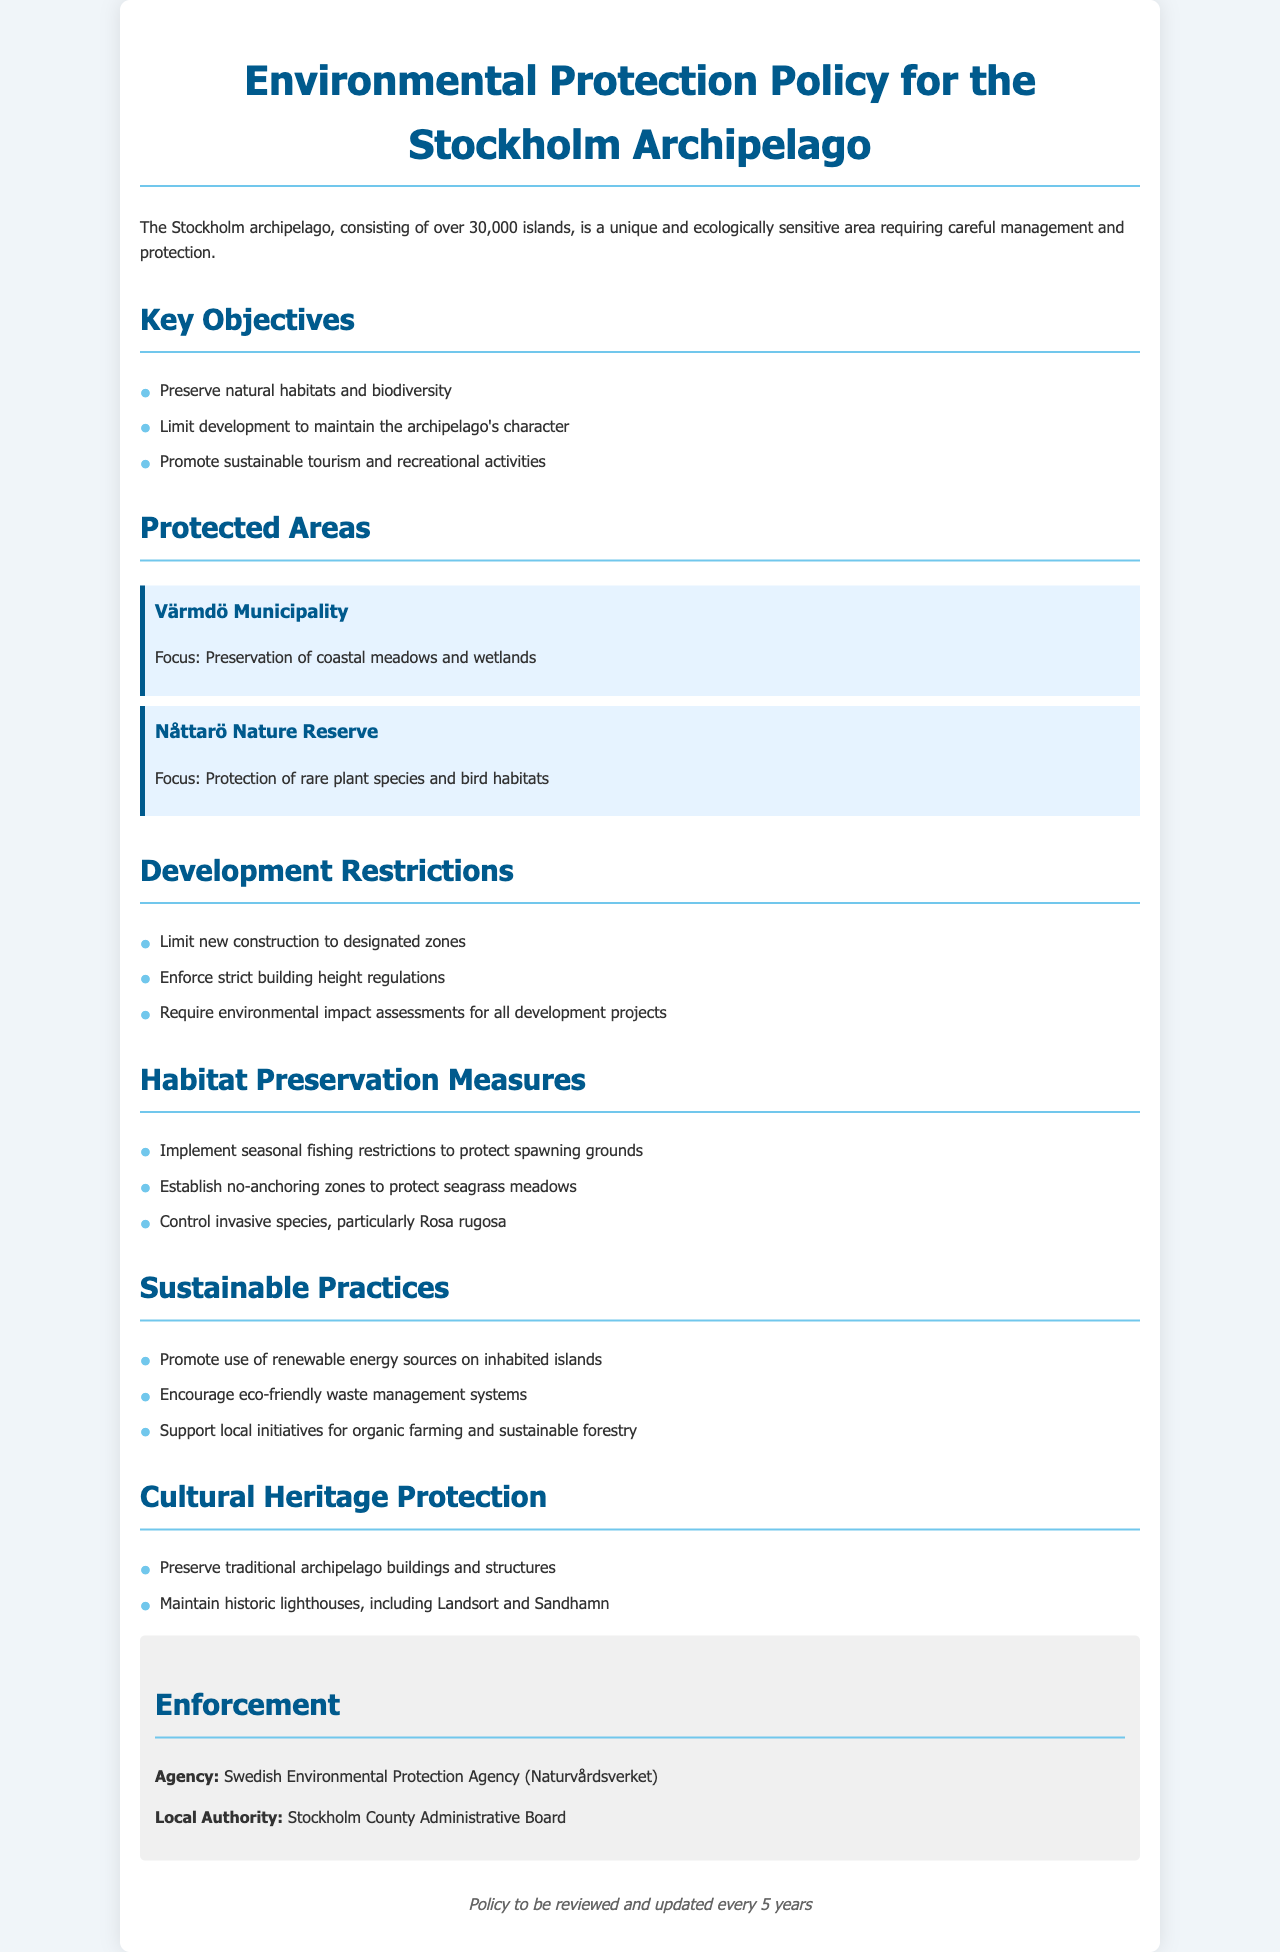What are the key objectives of the policy? The key objectives are outlined in a list within the document, including preservation of natural habitats and biodiversity, limiting development, and promoting sustainable tourism.
Answer: Preserve natural habitats and biodiversity, limit development, promote sustainable tourism Which protected area focuses on coastal meadows and wetlands? The document lists specific protected areas and their focuses, including one that specifically mentions coastal meadows and wetlands.
Answer: Värmdö Municipality What is the enforcement agency for this policy? The document specifies the agency responsible for enforcing the policy, which is stated clearly in the enforcement section.
Answer: Swedish Environmental Protection Agency (Naturvårdsverket) How often will the policy be reviewed? A review period is mentioned at the end of the document, indicating how frequently the policy will be evaluated for updates.
Answer: Every 5 years What type of fishing restrictions are implemented? The document mentions measures for habitat preservation, including specific practices regarding fishing restrictions.
Answer: Seasonal fishing restrictions What are the building height regulations described in the policy? The document states development restrictions, including specific requirements about construction, which includes details about building height.
Answer: Strict building height regulations What does the policy support in terms of sustainable practices? The document outlines a list of sustainable practices that the policy encourages, highlighting key areas for support.
Answer: Use of renewable energy sources Which traditional structures are to be preserved under the policy? Cultural heritage protection measures are detailed in the document, specifically mentioning types of structures for preservation.
Answer: Traditional archipelago buildings and structures 